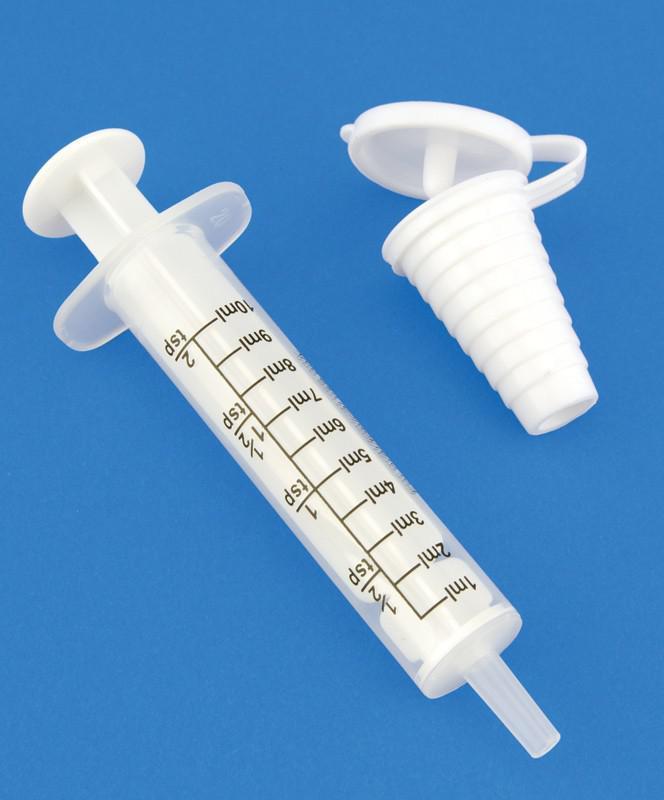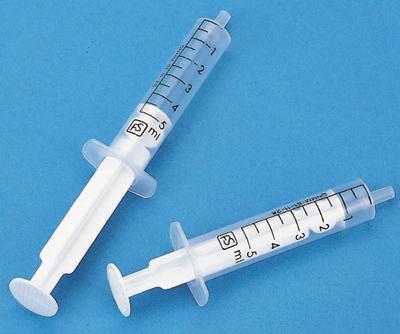The first image is the image on the left, the second image is the image on the right. Analyze the images presented: Is the assertion "Left image shows exactly one syringe-type item, with a green plunger." valid? Answer yes or no. No. The first image is the image on the left, the second image is the image on the right. For the images shown, is this caption "There is a single green syringe in the left image" true? Answer yes or no. No. 